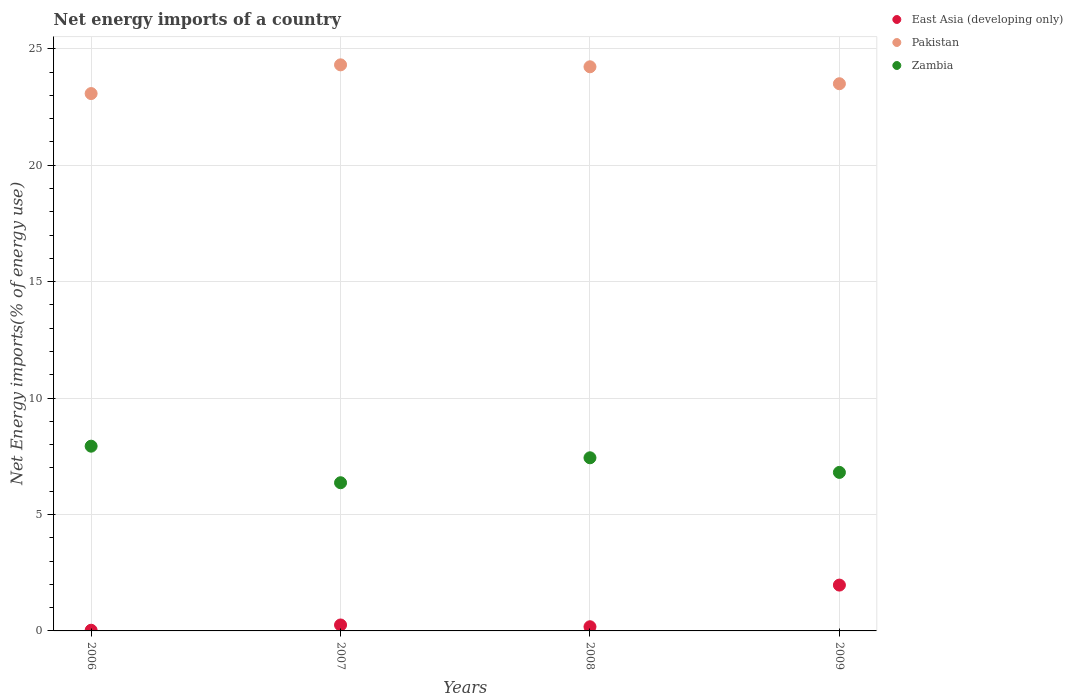What is the net energy imports in East Asia (developing only) in 2009?
Make the answer very short. 1.97. Across all years, what is the maximum net energy imports in Zambia?
Your answer should be compact. 7.93. Across all years, what is the minimum net energy imports in Pakistan?
Provide a succinct answer. 23.08. In which year was the net energy imports in East Asia (developing only) minimum?
Ensure brevity in your answer.  2006. What is the total net energy imports in Zambia in the graph?
Your answer should be compact. 28.54. What is the difference between the net energy imports in Zambia in 2006 and that in 2008?
Offer a very short reply. 0.5. What is the difference between the net energy imports in Pakistan in 2007 and the net energy imports in Zambia in 2009?
Offer a terse response. 17.5. What is the average net energy imports in Zambia per year?
Offer a terse response. 7.14. In the year 2006, what is the difference between the net energy imports in East Asia (developing only) and net energy imports in Zambia?
Provide a short and direct response. -7.91. In how many years, is the net energy imports in East Asia (developing only) greater than 2 %?
Your response must be concise. 0. What is the ratio of the net energy imports in East Asia (developing only) in 2006 to that in 2008?
Your answer should be compact. 0.16. Is the difference between the net energy imports in East Asia (developing only) in 2006 and 2008 greater than the difference between the net energy imports in Zambia in 2006 and 2008?
Provide a short and direct response. No. What is the difference between the highest and the second highest net energy imports in East Asia (developing only)?
Provide a succinct answer. 1.71. What is the difference between the highest and the lowest net energy imports in Zambia?
Your answer should be compact. 1.57. Is the sum of the net energy imports in Pakistan in 2006 and 2007 greater than the maximum net energy imports in East Asia (developing only) across all years?
Provide a short and direct response. Yes. Is it the case that in every year, the sum of the net energy imports in Zambia and net energy imports in Pakistan  is greater than the net energy imports in East Asia (developing only)?
Make the answer very short. Yes. Does the net energy imports in Zambia monotonically increase over the years?
Your answer should be compact. No. Is the net energy imports in East Asia (developing only) strictly less than the net energy imports in Zambia over the years?
Ensure brevity in your answer.  Yes. How many dotlines are there?
Provide a short and direct response. 3. Are the values on the major ticks of Y-axis written in scientific E-notation?
Make the answer very short. No. How many legend labels are there?
Keep it short and to the point. 3. How are the legend labels stacked?
Make the answer very short. Vertical. What is the title of the graph?
Offer a very short reply. Net energy imports of a country. Does "South Asia" appear as one of the legend labels in the graph?
Your answer should be compact. No. What is the label or title of the X-axis?
Your answer should be very brief. Years. What is the label or title of the Y-axis?
Offer a very short reply. Net Energy imports(% of energy use). What is the Net Energy imports(% of energy use) in East Asia (developing only) in 2006?
Make the answer very short. 0.03. What is the Net Energy imports(% of energy use) in Pakistan in 2006?
Your answer should be very brief. 23.08. What is the Net Energy imports(% of energy use) of Zambia in 2006?
Provide a succinct answer. 7.93. What is the Net Energy imports(% of energy use) in East Asia (developing only) in 2007?
Your answer should be compact. 0.26. What is the Net Energy imports(% of energy use) in Pakistan in 2007?
Provide a short and direct response. 24.31. What is the Net Energy imports(% of energy use) of Zambia in 2007?
Ensure brevity in your answer.  6.36. What is the Net Energy imports(% of energy use) in East Asia (developing only) in 2008?
Provide a short and direct response. 0.18. What is the Net Energy imports(% of energy use) of Pakistan in 2008?
Provide a succinct answer. 24.23. What is the Net Energy imports(% of energy use) of Zambia in 2008?
Make the answer very short. 7.44. What is the Net Energy imports(% of energy use) in East Asia (developing only) in 2009?
Your response must be concise. 1.97. What is the Net Energy imports(% of energy use) of Pakistan in 2009?
Your response must be concise. 23.5. What is the Net Energy imports(% of energy use) in Zambia in 2009?
Your answer should be very brief. 6.81. Across all years, what is the maximum Net Energy imports(% of energy use) in East Asia (developing only)?
Offer a very short reply. 1.97. Across all years, what is the maximum Net Energy imports(% of energy use) of Pakistan?
Your answer should be compact. 24.31. Across all years, what is the maximum Net Energy imports(% of energy use) in Zambia?
Give a very brief answer. 7.93. Across all years, what is the minimum Net Energy imports(% of energy use) of East Asia (developing only)?
Offer a terse response. 0.03. Across all years, what is the minimum Net Energy imports(% of energy use) in Pakistan?
Provide a succinct answer. 23.08. Across all years, what is the minimum Net Energy imports(% of energy use) in Zambia?
Ensure brevity in your answer.  6.36. What is the total Net Energy imports(% of energy use) of East Asia (developing only) in the graph?
Ensure brevity in your answer.  2.43. What is the total Net Energy imports(% of energy use) in Pakistan in the graph?
Provide a short and direct response. 95.12. What is the total Net Energy imports(% of energy use) of Zambia in the graph?
Your answer should be compact. 28.54. What is the difference between the Net Energy imports(% of energy use) in East Asia (developing only) in 2006 and that in 2007?
Your response must be concise. -0.23. What is the difference between the Net Energy imports(% of energy use) in Pakistan in 2006 and that in 2007?
Offer a terse response. -1.23. What is the difference between the Net Energy imports(% of energy use) of Zambia in 2006 and that in 2007?
Provide a succinct answer. 1.57. What is the difference between the Net Energy imports(% of energy use) in East Asia (developing only) in 2006 and that in 2008?
Give a very brief answer. -0.15. What is the difference between the Net Energy imports(% of energy use) of Pakistan in 2006 and that in 2008?
Keep it short and to the point. -1.15. What is the difference between the Net Energy imports(% of energy use) of Zambia in 2006 and that in 2008?
Your response must be concise. 0.5. What is the difference between the Net Energy imports(% of energy use) of East Asia (developing only) in 2006 and that in 2009?
Keep it short and to the point. -1.94. What is the difference between the Net Energy imports(% of energy use) in Pakistan in 2006 and that in 2009?
Offer a terse response. -0.42. What is the difference between the Net Energy imports(% of energy use) of Zambia in 2006 and that in 2009?
Provide a short and direct response. 1.13. What is the difference between the Net Energy imports(% of energy use) in East Asia (developing only) in 2007 and that in 2008?
Your answer should be compact. 0.08. What is the difference between the Net Energy imports(% of energy use) of Pakistan in 2007 and that in 2008?
Offer a very short reply. 0.08. What is the difference between the Net Energy imports(% of energy use) of Zambia in 2007 and that in 2008?
Give a very brief answer. -1.07. What is the difference between the Net Energy imports(% of energy use) of East Asia (developing only) in 2007 and that in 2009?
Offer a very short reply. -1.71. What is the difference between the Net Energy imports(% of energy use) in Pakistan in 2007 and that in 2009?
Your answer should be very brief. 0.81. What is the difference between the Net Energy imports(% of energy use) of Zambia in 2007 and that in 2009?
Ensure brevity in your answer.  -0.44. What is the difference between the Net Energy imports(% of energy use) in East Asia (developing only) in 2008 and that in 2009?
Your answer should be very brief. -1.79. What is the difference between the Net Energy imports(% of energy use) in Pakistan in 2008 and that in 2009?
Provide a short and direct response. 0.73. What is the difference between the Net Energy imports(% of energy use) of Zambia in 2008 and that in 2009?
Your answer should be compact. 0.63. What is the difference between the Net Energy imports(% of energy use) of East Asia (developing only) in 2006 and the Net Energy imports(% of energy use) of Pakistan in 2007?
Ensure brevity in your answer.  -24.28. What is the difference between the Net Energy imports(% of energy use) of East Asia (developing only) in 2006 and the Net Energy imports(% of energy use) of Zambia in 2007?
Provide a succinct answer. -6.34. What is the difference between the Net Energy imports(% of energy use) of Pakistan in 2006 and the Net Energy imports(% of energy use) of Zambia in 2007?
Your response must be concise. 16.71. What is the difference between the Net Energy imports(% of energy use) of East Asia (developing only) in 2006 and the Net Energy imports(% of energy use) of Pakistan in 2008?
Your response must be concise. -24.2. What is the difference between the Net Energy imports(% of energy use) of East Asia (developing only) in 2006 and the Net Energy imports(% of energy use) of Zambia in 2008?
Provide a short and direct response. -7.41. What is the difference between the Net Energy imports(% of energy use) of Pakistan in 2006 and the Net Energy imports(% of energy use) of Zambia in 2008?
Provide a succinct answer. 15.64. What is the difference between the Net Energy imports(% of energy use) in East Asia (developing only) in 2006 and the Net Energy imports(% of energy use) in Pakistan in 2009?
Provide a short and direct response. -23.47. What is the difference between the Net Energy imports(% of energy use) in East Asia (developing only) in 2006 and the Net Energy imports(% of energy use) in Zambia in 2009?
Offer a very short reply. -6.78. What is the difference between the Net Energy imports(% of energy use) in Pakistan in 2006 and the Net Energy imports(% of energy use) in Zambia in 2009?
Your response must be concise. 16.27. What is the difference between the Net Energy imports(% of energy use) of East Asia (developing only) in 2007 and the Net Energy imports(% of energy use) of Pakistan in 2008?
Offer a terse response. -23.97. What is the difference between the Net Energy imports(% of energy use) in East Asia (developing only) in 2007 and the Net Energy imports(% of energy use) in Zambia in 2008?
Your response must be concise. -7.18. What is the difference between the Net Energy imports(% of energy use) of Pakistan in 2007 and the Net Energy imports(% of energy use) of Zambia in 2008?
Your answer should be very brief. 16.88. What is the difference between the Net Energy imports(% of energy use) of East Asia (developing only) in 2007 and the Net Energy imports(% of energy use) of Pakistan in 2009?
Make the answer very short. -23.25. What is the difference between the Net Energy imports(% of energy use) in East Asia (developing only) in 2007 and the Net Energy imports(% of energy use) in Zambia in 2009?
Make the answer very short. -6.55. What is the difference between the Net Energy imports(% of energy use) in Pakistan in 2007 and the Net Energy imports(% of energy use) in Zambia in 2009?
Your response must be concise. 17.5. What is the difference between the Net Energy imports(% of energy use) in East Asia (developing only) in 2008 and the Net Energy imports(% of energy use) in Pakistan in 2009?
Ensure brevity in your answer.  -23.32. What is the difference between the Net Energy imports(% of energy use) in East Asia (developing only) in 2008 and the Net Energy imports(% of energy use) in Zambia in 2009?
Offer a terse response. -6.63. What is the difference between the Net Energy imports(% of energy use) in Pakistan in 2008 and the Net Energy imports(% of energy use) in Zambia in 2009?
Your answer should be very brief. 17.42. What is the average Net Energy imports(% of energy use) in East Asia (developing only) per year?
Make the answer very short. 0.61. What is the average Net Energy imports(% of energy use) of Pakistan per year?
Make the answer very short. 23.78. What is the average Net Energy imports(% of energy use) of Zambia per year?
Provide a short and direct response. 7.14. In the year 2006, what is the difference between the Net Energy imports(% of energy use) in East Asia (developing only) and Net Energy imports(% of energy use) in Pakistan?
Provide a short and direct response. -23.05. In the year 2006, what is the difference between the Net Energy imports(% of energy use) in East Asia (developing only) and Net Energy imports(% of energy use) in Zambia?
Your response must be concise. -7.91. In the year 2006, what is the difference between the Net Energy imports(% of energy use) in Pakistan and Net Energy imports(% of energy use) in Zambia?
Offer a very short reply. 15.14. In the year 2007, what is the difference between the Net Energy imports(% of energy use) of East Asia (developing only) and Net Energy imports(% of energy use) of Pakistan?
Your response must be concise. -24.06. In the year 2007, what is the difference between the Net Energy imports(% of energy use) of East Asia (developing only) and Net Energy imports(% of energy use) of Zambia?
Provide a short and direct response. -6.11. In the year 2007, what is the difference between the Net Energy imports(% of energy use) of Pakistan and Net Energy imports(% of energy use) of Zambia?
Offer a very short reply. 17.95. In the year 2008, what is the difference between the Net Energy imports(% of energy use) in East Asia (developing only) and Net Energy imports(% of energy use) in Pakistan?
Your response must be concise. -24.05. In the year 2008, what is the difference between the Net Energy imports(% of energy use) in East Asia (developing only) and Net Energy imports(% of energy use) in Zambia?
Your answer should be very brief. -7.26. In the year 2008, what is the difference between the Net Energy imports(% of energy use) of Pakistan and Net Energy imports(% of energy use) of Zambia?
Your response must be concise. 16.79. In the year 2009, what is the difference between the Net Energy imports(% of energy use) of East Asia (developing only) and Net Energy imports(% of energy use) of Pakistan?
Your response must be concise. -21.53. In the year 2009, what is the difference between the Net Energy imports(% of energy use) in East Asia (developing only) and Net Energy imports(% of energy use) in Zambia?
Provide a short and direct response. -4.84. In the year 2009, what is the difference between the Net Energy imports(% of energy use) in Pakistan and Net Energy imports(% of energy use) in Zambia?
Offer a very short reply. 16.69. What is the ratio of the Net Energy imports(% of energy use) of East Asia (developing only) in 2006 to that in 2007?
Offer a very short reply. 0.11. What is the ratio of the Net Energy imports(% of energy use) of Pakistan in 2006 to that in 2007?
Offer a very short reply. 0.95. What is the ratio of the Net Energy imports(% of energy use) in Zambia in 2006 to that in 2007?
Provide a succinct answer. 1.25. What is the ratio of the Net Energy imports(% of energy use) in East Asia (developing only) in 2006 to that in 2008?
Offer a very short reply. 0.16. What is the ratio of the Net Energy imports(% of energy use) in Pakistan in 2006 to that in 2008?
Give a very brief answer. 0.95. What is the ratio of the Net Energy imports(% of energy use) in Zambia in 2006 to that in 2008?
Your answer should be very brief. 1.07. What is the ratio of the Net Energy imports(% of energy use) in East Asia (developing only) in 2006 to that in 2009?
Provide a short and direct response. 0.01. What is the ratio of the Net Energy imports(% of energy use) in Pakistan in 2006 to that in 2009?
Your answer should be compact. 0.98. What is the ratio of the Net Energy imports(% of energy use) of Zambia in 2006 to that in 2009?
Ensure brevity in your answer.  1.17. What is the ratio of the Net Energy imports(% of energy use) of East Asia (developing only) in 2007 to that in 2008?
Provide a succinct answer. 1.43. What is the ratio of the Net Energy imports(% of energy use) in Zambia in 2007 to that in 2008?
Your answer should be compact. 0.86. What is the ratio of the Net Energy imports(% of energy use) of East Asia (developing only) in 2007 to that in 2009?
Your response must be concise. 0.13. What is the ratio of the Net Energy imports(% of energy use) of Pakistan in 2007 to that in 2009?
Give a very brief answer. 1.03. What is the ratio of the Net Energy imports(% of energy use) of Zambia in 2007 to that in 2009?
Offer a terse response. 0.93. What is the ratio of the Net Energy imports(% of energy use) of East Asia (developing only) in 2008 to that in 2009?
Your answer should be compact. 0.09. What is the ratio of the Net Energy imports(% of energy use) of Pakistan in 2008 to that in 2009?
Your response must be concise. 1.03. What is the ratio of the Net Energy imports(% of energy use) of Zambia in 2008 to that in 2009?
Make the answer very short. 1.09. What is the difference between the highest and the second highest Net Energy imports(% of energy use) of East Asia (developing only)?
Offer a terse response. 1.71. What is the difference between the highest and the second highest Net Energy imports(% of energy use) in Pakistan?
Offer a terse response. 0.08. What is the difference between the highest and the second highest Net Energy imports(% of energy use) in Zambia?
Offer a very short reply. 0.5. What is the difference between the highest and the lowest Net Energy imports(% of energy use) in East Asia (developing only)?
Provide a succinct answer. 1.94. What is the difference between the highest and the lowest Net Energy imports(% of energy use) of Pakistan?
Provide a short and direct response. 1.23. What is the difference between the highest and the lowest Net Energy imports(% of energy use) in Zambia?
Offer a very short reply. 1.57. 